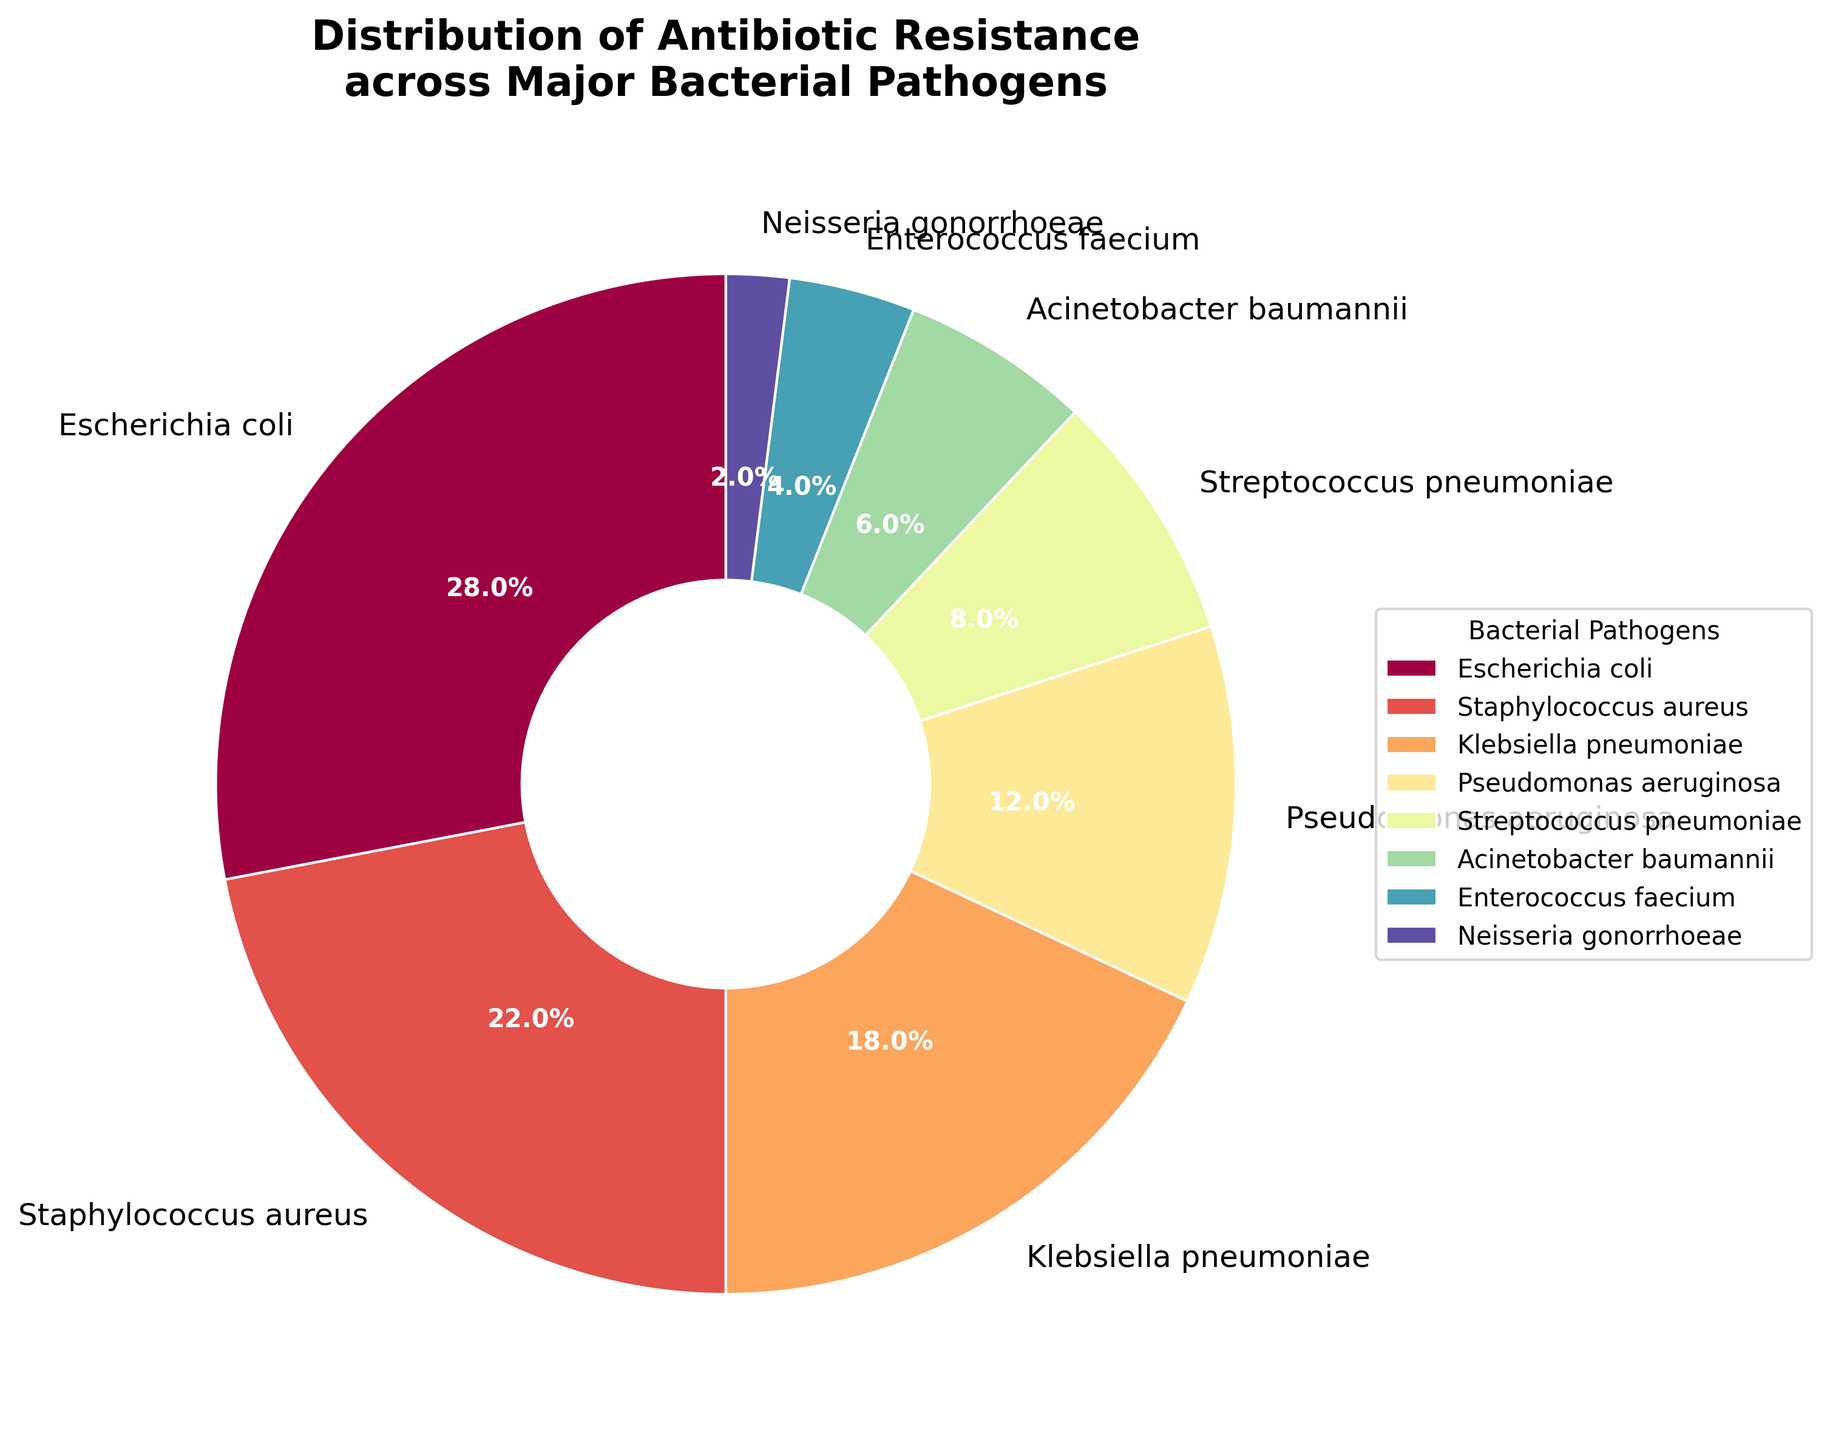Which bacterial pathogen shows the highest percentage of antibiotic-resistant strains? The bacterial pathogen with the largest slice in the pie chart represents the highest percentage. Here, Escherichia coli has the largest portion.
Answer: Escherichia coli Which bacterial pathogen has the lowest percentage of antibiotic-resistant strains? The bacterial pathogen with the smallest slice in the pie chart represents the lowest percentage. Neisseria gonorrhoeae has the smallest portion.
Answer: Neisseria gonorrhoeae What is the total percentage of antibiotic-resistant strains for Staphylococcus aureus and Klebsiella pneumoniae combined? Add the percentages of Staphylococcus aureus (22%) and Klebsiella pneumoniae (18%). 22% + 18% = 40%.
Answer: 40% Are there more antibiotic-resistant strains in Pseudomonas aeruginosa or Streptococcus pneumoniae? Compare the percentages of Pseudomonas aeruginosa (12%) and Streptococcus pneumoniae (8%). Pseudomonas aeruginosa has a higher percentage.
Answer: Pseudomonas aeruginosa What is the difference in percentage between Acinetobacter baumannii and Enterococcus faecium? Subtract the percentage of Enterococcus faecium (4%) from Acinetobacter baumannii (6%). 6% - 4% = 2%.
Answer: 2% What is the average percentage of antibiotic resistance for Neisseria gonorrhoeae, Enterococcus faecium, and Acinetobacter baumannii? Sum the percentages of Neisseria gonorrhoeae (2%), Enterococcus faecium (4%), and Acinetobacter baumannii (6%), and divide by 3. (2% + 4% + 6%) / 3 = 4%.
Answer: 4% Arrange the bacterial pathogens in ascending order of their antibiotic-resistant strain percentages. List the pathogens from the smallest to the largest percentage: Neisseria gonorrhoeae (2%), Enterococcus faecium (4%), Acinetobacter baumannii (6%), Streptococcus pneumoniae (8%), Pseudomonas aeruginosa (12%), Klebsiella pneumoniae (18%), Staphylococcus aureus (22%), Escherichia coli (28%).
Answer: Neisseria gonorrhoeae, Enterococcus faecium, Acinetobacter baumannii, Streptococcus pneumoniae, Pseudomonas aeruginosa, Klebsiella pneumoniae, Staphylococcus aureus, Escherichia coli What proportion of the antibiotic-resistant strains are due to Escherichia coli out of the total displayed on the pie chart? Since Escherichia coli contributes 28% and the total is assumed to be 100%, the proportion is 28 out of 100. (28/100) = 28%.
Answer: 28% What percentage would be represented if Streptococcus pneumoniae and Pseudomonas aeruginosa were combined into one category? Add the percentages of Streptococcus pneumoniae (8%) and Pseudomonas aeruginosa (12%). 8% + 12% = 20%.
Answer: 20% Which two pathogens combined contribute exactly 14% of antibiotic-resistant strains? First, observe the smaller slices. Adding 6% (Acinetobacter baumannii) and 8% (Streptococcus pneumoniae) results in a sum of 14%; thus, the combined contribution of these two pathogens is 14%.
Answer: Acinetobacter baumannii and Streptococcus pneumoniae 